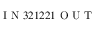<formula> <loc_0><loc_0><loc_500><loc_500>I N 3 2 1 2 2 1 O U T</formula> 